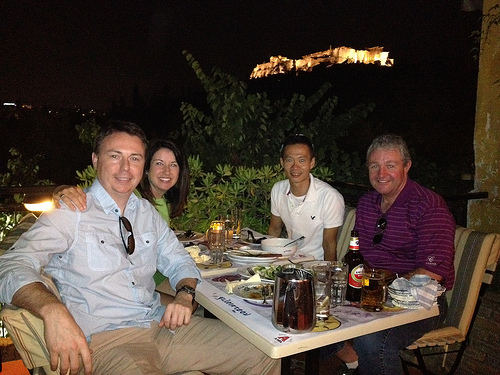How many people are smiling? In the image, it appears that two out of the four people are smiling broadly, enjoying a pleasant moment together. 